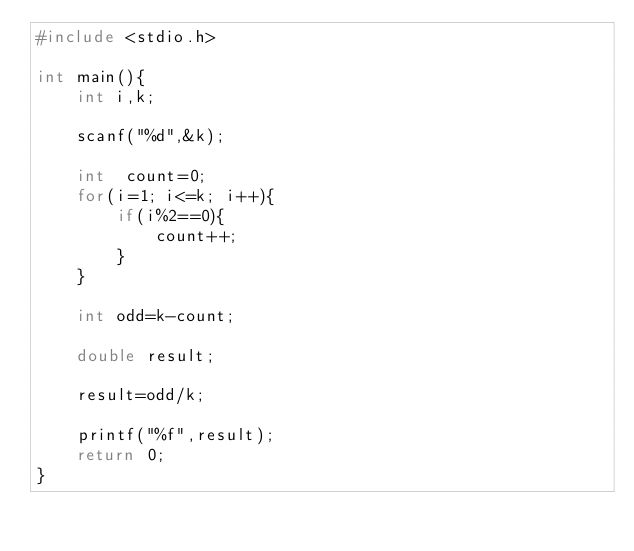Convert code to text. <code><loc_0><loc_0><loc_500><loc_500><_C_>#include <stdio.h>

int main(){
	int i,k;

	scanf("%d",&k);

	int  count=0;
	for(i=1; i<=k; i++){
		if(i%2==0){
			count++;
		}
	}
	
	int odd=k-count;

	double result;

	result=odd/k;

	printf("%f",result);
	return 0;
}</code> 